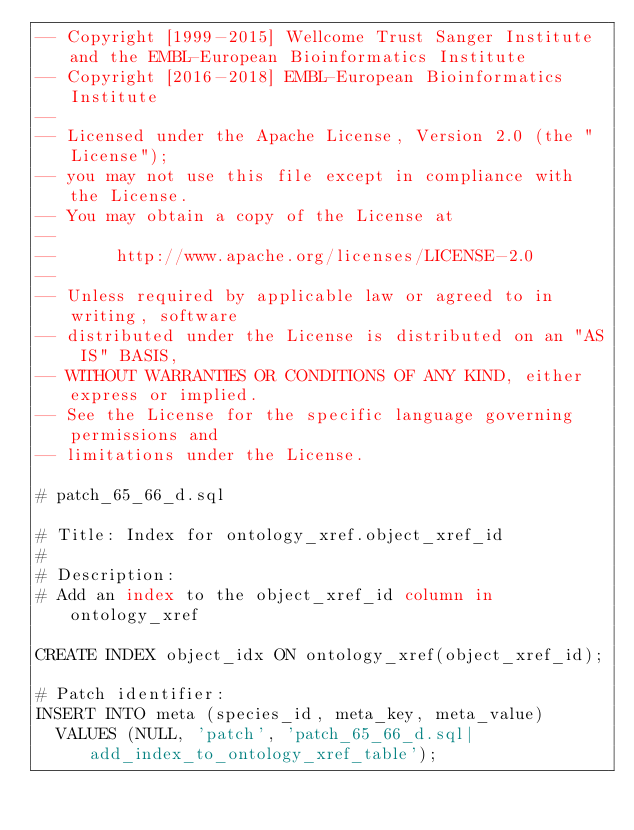<code> <loc_0><loc_0><loc_500><loc_500><_SQL_>-- Copyright [1999-2015] Wellcome Trust Sanger Institute and the EMBL-European Bioinformatics Institute
-- Copyright [2016-2018] EMBL-European Bioinformatics Institute
-- 
-- Licensed under the Apache License, Version 2.0 (the "License");
-- you may not use this file except in compliance with the License.
-- You may obtain a copy of the License at
-- 
--      http://www.apache.org/licenses/LICENSE-2.0
-- 
-- Unless required by applicable law or agreed to in writing, software
-- distributed under the License is distributed on an "AS IS" BASIS,
-- WITHOUT WARRANTIES OR CONDITIONS OF ANY KIND, either express or implied.
-- See the License for the specific language governing permissions and
-- limitations under the License.

# patch_65_66_d.sql

# Title: Index for ontology_xref.object_xref_id
#
# Description:
# Add an index to the object_xref_id column in ontology_xref

CREATE INDEX object_idx ON ontology_xref(object_xref_id);

# Patch identifier:
INSERT INTO meta (species_id, meta_key, meta_value)
  VALUES (NULL, 'patch', 'patch_65_66_d.sql|add_index_to_ontology_xref_table');
</code> 